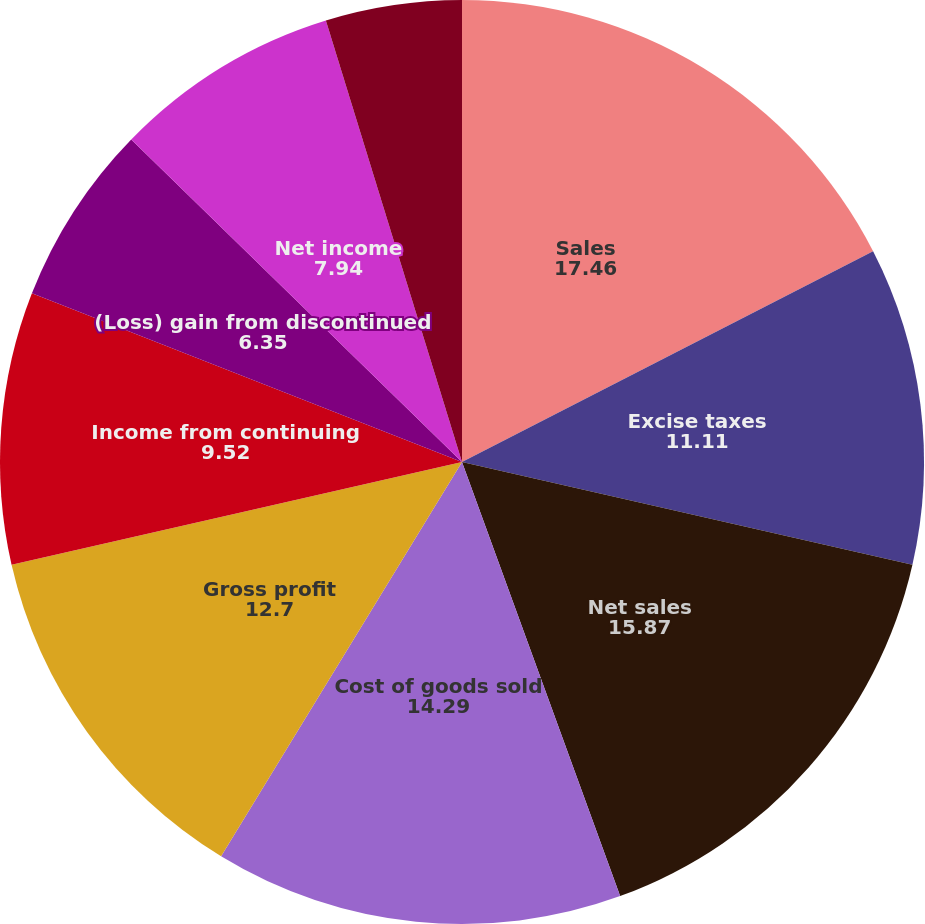Convert chart to OTSL. <chart><loc_0><loc_0><loc_500><loc_500><pie_chart><fcel>Sales<fcel>Excise taxes<fcel>Net sales<fcel>Cost of goods sold<fcel>Gross profit<fcel>Income from continuing<fcel>(Loss) gain from discontinued<fcel>Net income<fcel>From continuing operations<fcel>From discontinued operations<nl><fcel>17.46%<fcel>11.11%<fcel>15.87%<fcel>14.29%<fcel>12.7%<fcel>9.52%<fcel>6.35%<fcel>7.94%<fcel>4.76%<fcel>0.0%<nl></chart> 